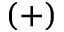<formula> <loc_0><loc_0><loc_500><loc_500>( + )</formula> 